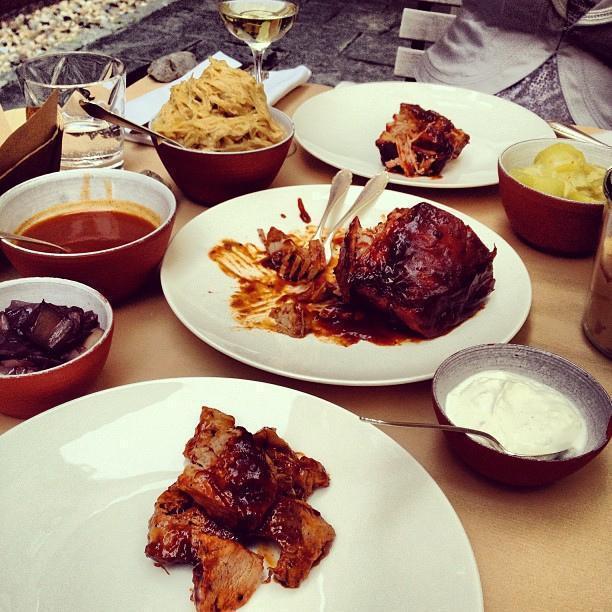What type feast is being served here?
Pick the right solution, then justify: 'Answer: answer
Rationale: rationale.'
Options: Burger grill, barbeque, fish fry, clam bake. Answer: barbeque.
Rationale: As indicated by the grilled parts of meat and many sauces. the foods necessary for the other options aren't in the image. 